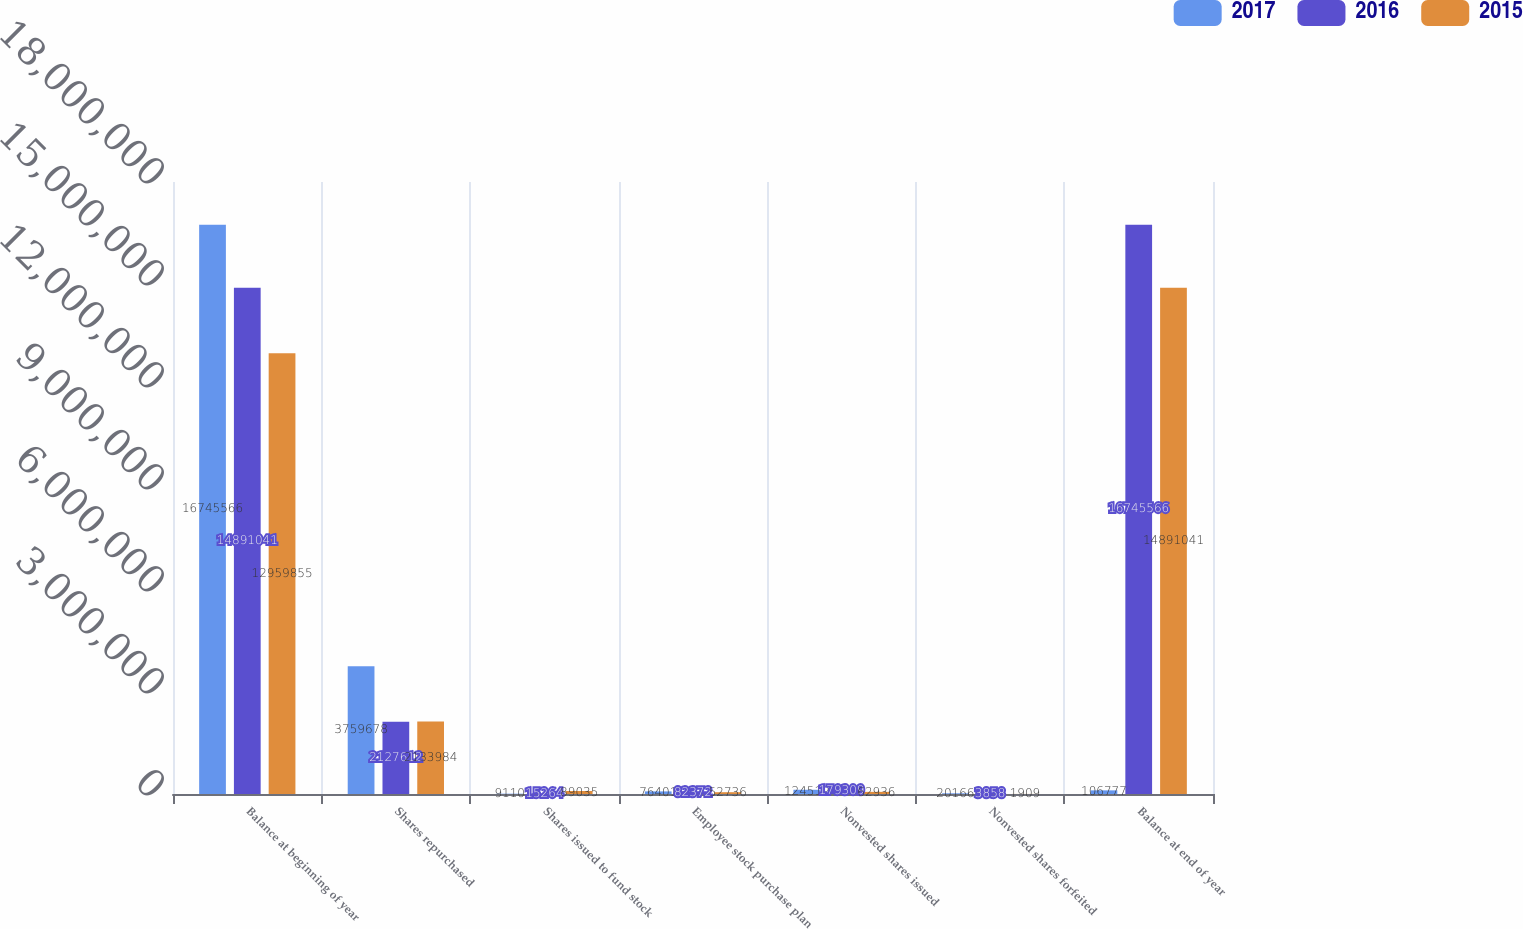<chart> <loc_0><loc_0><loc_500><loc_500><stacked_bar_chart><ecel><fcel>Balance at beginning of year<fcel>Shares repurchased<fcel>Shares issued to fund stock<fcel>Employee stock purchase plan<fcel>Nonvested shares issued<fcel>Nonvested shares forfeited<fcel>Balance at end of year<nl><fcel>2017<fcel>1.67456e+07<fcel>3.75968e+06<fcel>9110<fcel>76401<fcel>124519<fcel>20166<fcel>106777<nl><fcel>2016<fcel>1.4891e+07<fcel>2.12761e+06<fcel>15264<fcel>82372<fcel>179309<fcel>3858<fcel>1.67456e+07<nl><fcel>2015<fcel>1.29599e+07<fcel>2.13398e+06<fcel>89035<fcel>52736<fcel>62936<fcel>1909<fcel>1.4891e+07<nl></chart> 